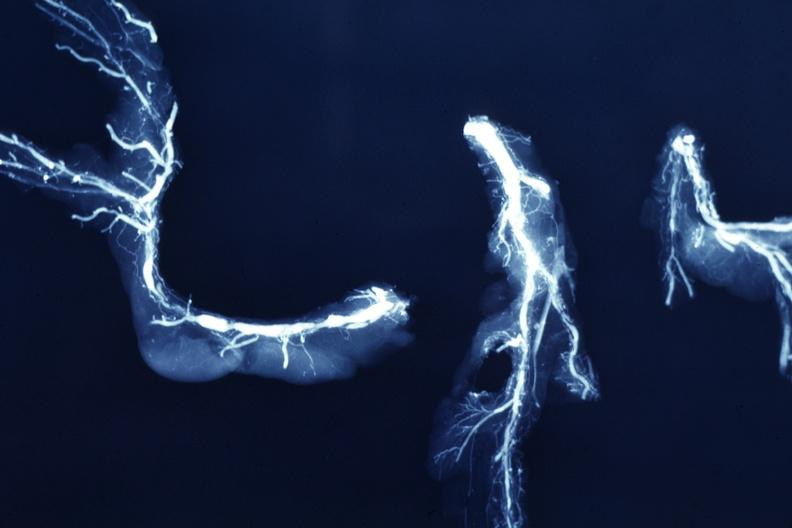how is x-ray postmortdissected arteries lesions?
Answer the question using a single word or phrase. Extensive 